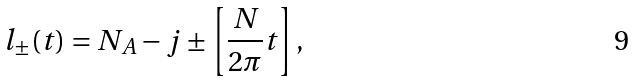<formula> <loc_0><loc_0><loc_500><loc_500>l _ { \pm } ( t ) = N _ { A } - j \pm \left [ \frac { N } { 2 \pi } t \right ] ,</formula> 